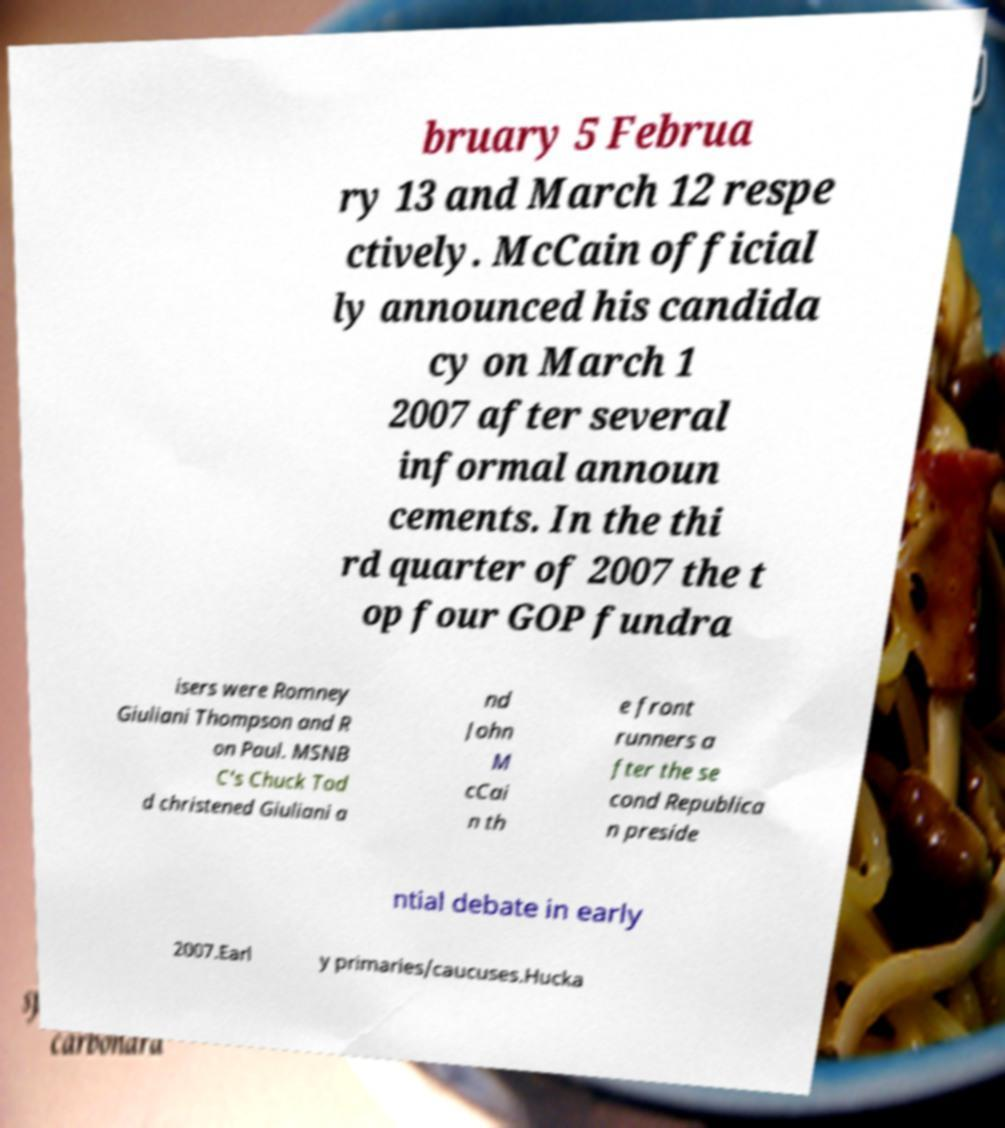What messages or text are displayed in this image? I need them in a readable, typed format. bruary 5 Februa ry 13 and March 12 respe ctively. McCain official ly announced his candida cy on March 1 2007 after several informal announ cements. In the thi rd quarter of 2007 the t op four GOP fundra isers were Romney Giuliani Thompson and R on Paul. MSNB C's Chuck Tod d christened Giuliani a nd John M cCai n th e front runners a fter the se cond Republica n preside ntial debate in early 2007.Earl y primaries/caucuses.Hucka 